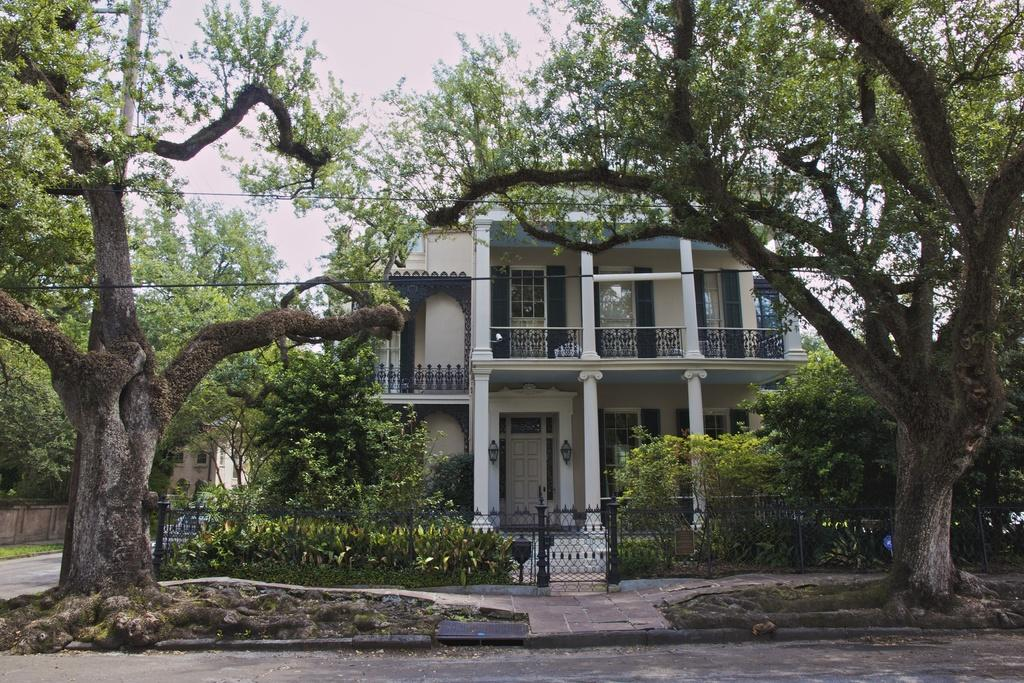What type of pathway is visible in the image? There is a road in the image. What type of natural elements can be seen in the image? There are trees and plants in the image. What type of structure is present in the image? There is a building in the image. What is the condition of the sky in the image? The sky is clear in the image. How many sheep are visible in the image? There are no sheep present in the image. What color is the toe of the building in the image? There is no mention of a toe or color associated with the building in the image. 